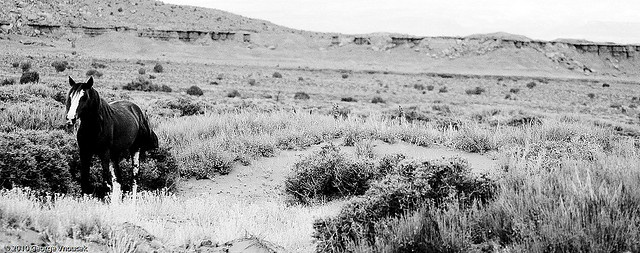Describe the objects in this image and their specific colors. I can see a horse in lightgray, black, gray, and darkgray tones in this image. 